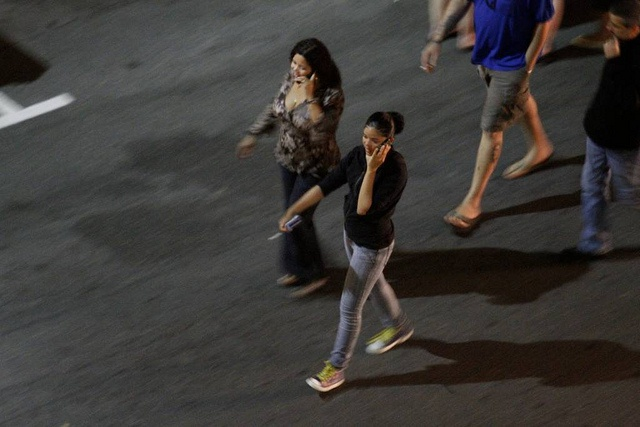Describe the objects in this image and their specific colors. I can see people in black, gray, and maroon tones, people in black, gray, and maroon tones, people in black, gray, navy, and maroon tones, people in black, maroon, and gray tones, and people in black, gray, and maroon tones in this image. 